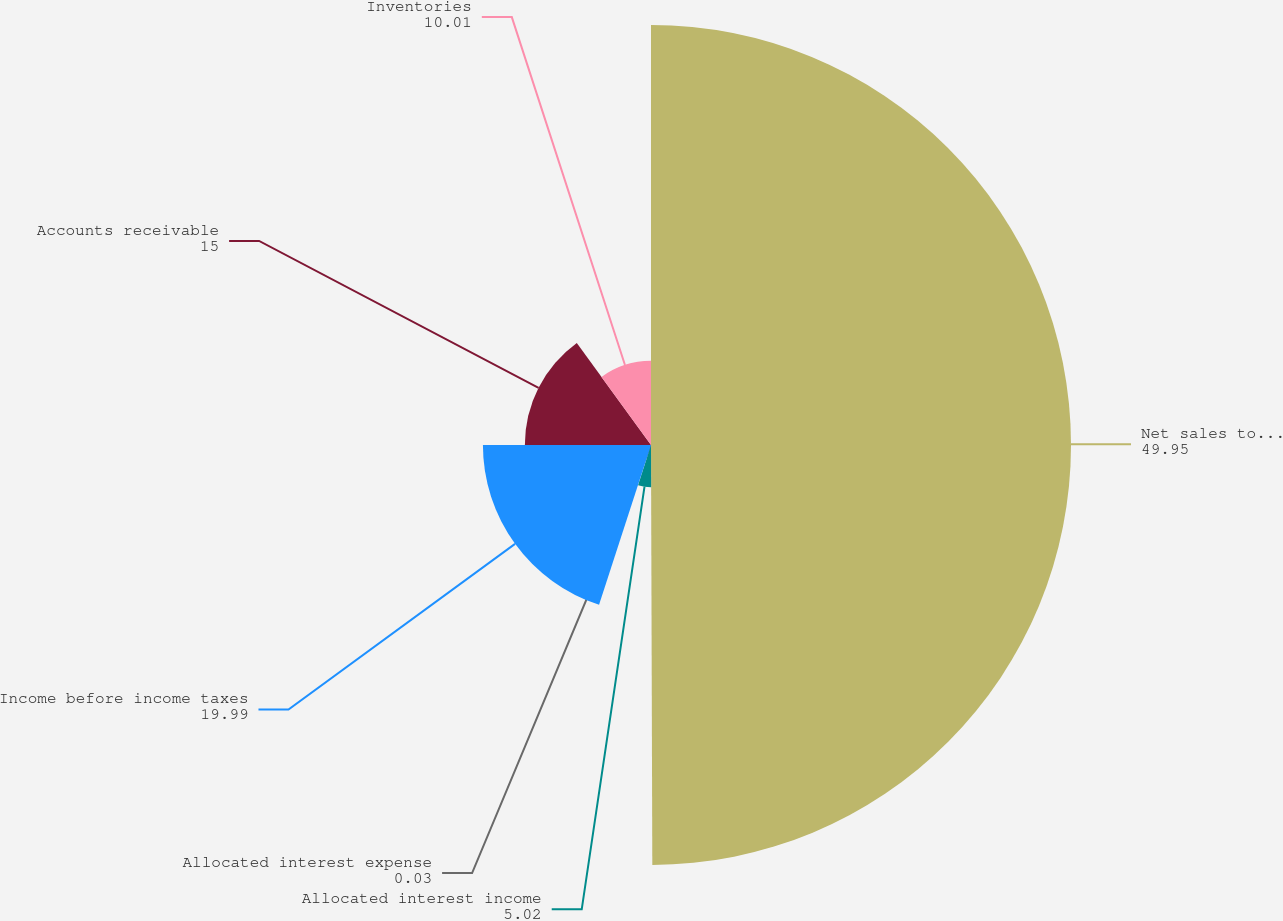Convert chart. <chart><loc_0><loc_0><loc_500><loc_500><pie_chart><fcel>Net sales to external<fcel>Allocated interest income<fcel>Allocated interest expense<fcel>Income before income taxes<fcel>Accounts receivable<fcel>Inventories<nl><fcel>49.95%<fcel>5.02%<fcel>0.03%<fcel>19.99%<fcel>15.0%<fcel>10.01%<nl></chart> 